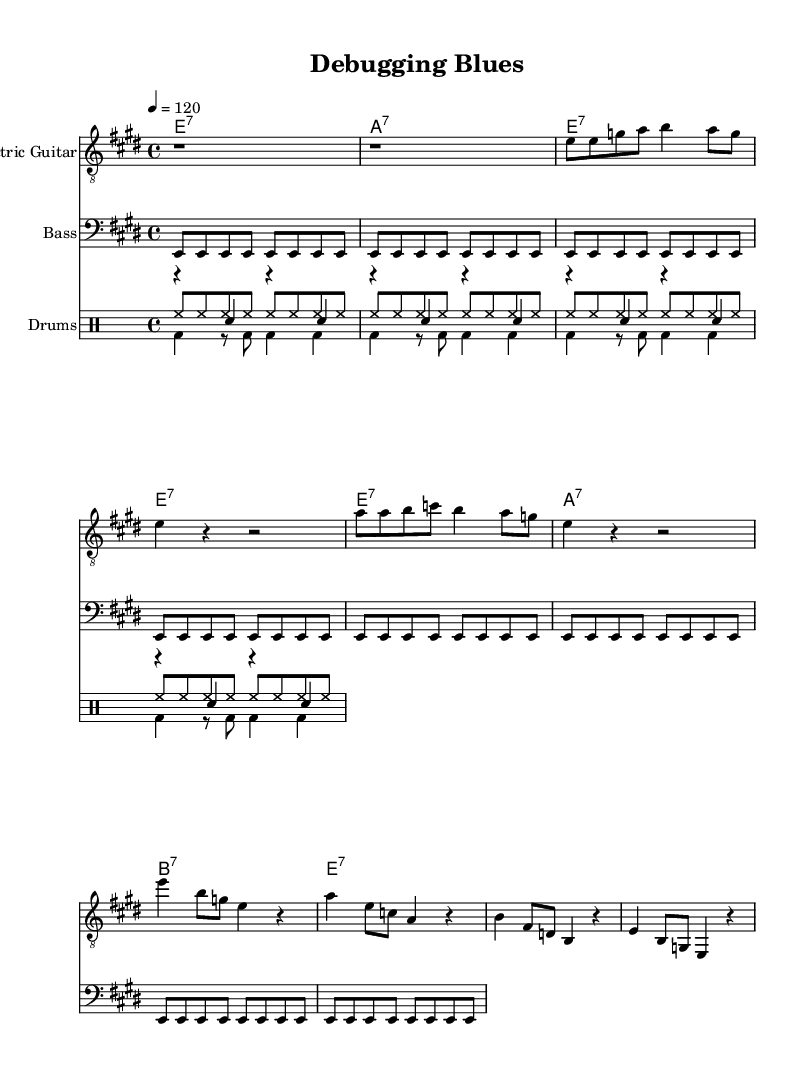What is the key signature of this music? The key signature is E major, which has four sharps: F#, C#, G#, and D#. This is derived from the 'key e' specified in the global section of the LilyPond code.
Answer: E major What is the time signature of this music? The time signature is 4/4, indicating that there are four beats per measure, and each quarter note gets one beat. This is specified in the global section of the code under '\time 4/4'.
Answer: 4/4 What is the tempo marking for this piece? The tempo marking is 120 beats per minute. This can be read in the global section of the code where it specifies '\tempo 4 = 120'.
Answer: 120 How many measures are in the verse section? There are 4 measures in the verse section of the music, which can be counted from the lyrics corresponding to the 'electricGuitar' notes in the verseWords.
Answer: 4 What is the first chord played in the piece? The first chord played is E7, as shown in the chordsGuitar section where the progression begins with 'e1:7' in the first measure.
Answer: E7 What type of rhythm is used in the bass guitar part? The rhythm used in the bass guitar part consists of eighth notes, as indicated by 'e,8' and repeated for 8 measures. The code includes 'unfold' to repeat this rhythm.
Answer: Eighth notes What is the lyrical theme presented in this music? The lyrical theme centers around coding challenges and debugging frustrations, as expressed in the words "Debugging through the night, feeling the stress." This reflects the essence of the Electric Blues, focusing on personal struggles.
Answer: Coding challenges 